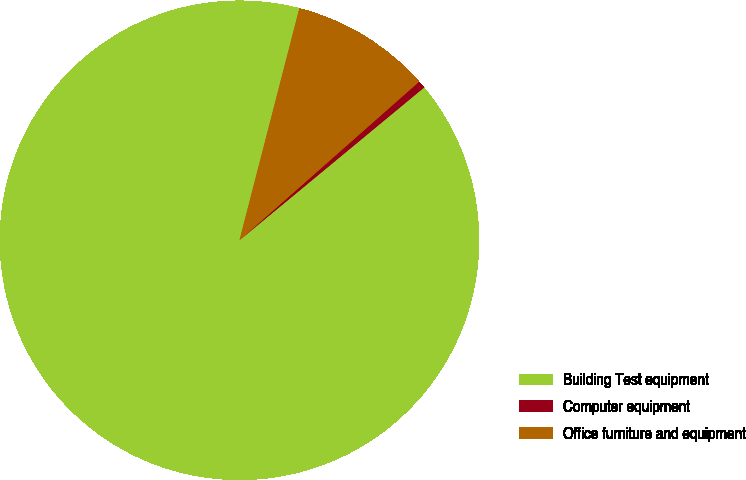Convert chart to OTSL. <chart><loc_0><loc_0><loc_500><loc_500><pie_chart><fcel>Building Test equipment<fcel>Computer equipment<fcel>Office furniture and equipment<nl><fcel>90.02%<fcel>0.51%<fcel>9.47%<nl></chart> 